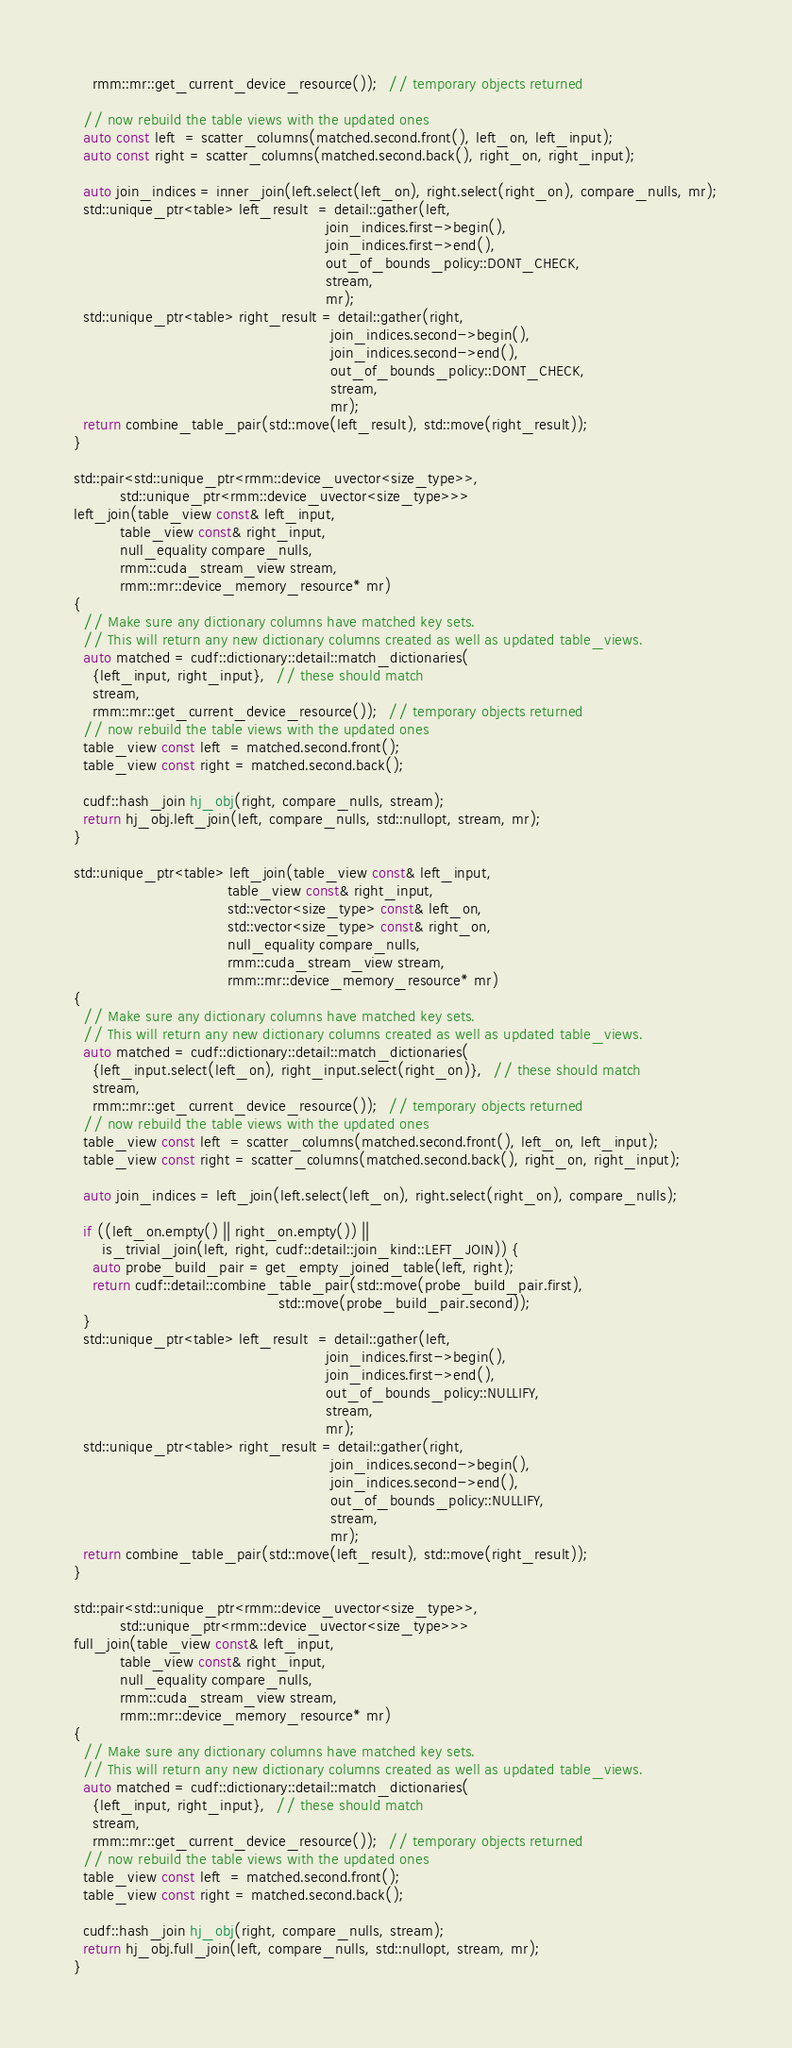Convert code to text. <code><loc_0><loc_0><loc_500><loc_500><_Cuda_>    rmm::mr::get_current_device_resource());  // temporary objects returned

  // now rebuild the table views with the updated ones
  auto const left  = scatter_columns(matched.second.front(), left_on, left_input);
  auto const right = scatter_columns(matched.second.back(), right_on, right_input);

  auto join_indices = inner_join(left.select(left_on), right.select(right_on), compare_nulls, mr);
  std::unique_ptr<table> left_result  = detail::gather(left,
                                                      join_indices.first->begin(),
                                                      join_indices.first->end(),
                                                      out_of_bounds_policy::DONT_CHECK,
                                                      stream,
                                                      mr);
  std::unique_ptr<table> right_result = detail::gather(right,
                                                       join_indices.second->begin(),
                                                       join_indices.second->end(),
                                                       out_of_bounds_policy::DONT_CHECK,
                                                       stream,
                                                       mr);
  return combine_table_pair(std::move(left_result), std::move(right_result));
}

std::pair<std::unique_ptr<rmm::device_uvector<size_type>>,
          std::unique_ptr<rmm::device_uvector<size_type>>>
left_join(table_view const& left_input,
          table_view const& right_input,
          null_equality compare_nulls,
          rmm::cuda_stream_view stream,
          rmm::mr::device_memory_resource* mr)
{
  // Make sure any dictionary columns have matched key sets.
  // This will return any new dictionary columns created as well as updated table_views.
  auto matched = cudf::dictionary::detail::match_dictionaries(
    {left_input, right_input},  // these should match
    stream,
    rmm::mr::get_current_device_resource());  // temporary objects returned
  // now rebuild the table views with the updated ones
  table_view const left  = matched.second.front();
  table_view const right = matched.second.back();

  cudf::hash_join hj_obj(right, compare_nulls, stream);
  return hj_obj.left_join(left, compare_nulls, std::nullopt, stream, mr);
}

std::unique_ptr<table> left_join(table_view const& left_input,
                                 table_view const& right_input,
                                 std::vector<size_type> const& left_on,
                                 std::vector<size_type> const& right_on,
                                 null_equality compare_nulls,
                                 rmm::cuda_stream_view stream,
                                 rmm::mr::device_memory_resource* mr)
{
  // Make sure any dictionary columns have matched key sets.
  // This will return any new dictionary columns created as well as updated table_views.
  auto matched = cudf::dictionary::detail::match_dictionaries(
    {left_input.select(left_on), right_input.select(right_on)},  // these should match
    stream,
    rmm::mr::get_current_device_resource());  // temporary objects returned
  // now rebuild the table views with the updated ones
  table_view const left  = scatter_columns(matched.second.front(), left_on, left_input);
  table_view const right = scatter_columns(matched.second.back(), right_on, right_input);

  auto join_indices = left_join(left.select(left_on), right.select(right_on), compare_nulls);

  if ((left_on.empty() || right_on.empty()) ||
      is_trivial_join(left, right, cudf::detail::join_kind::LEFT_JOIN)) {
    auto probe_build_pair = get_empty_joined_table(left, right);
    return cudf::detail::combine_table_pair(std::move(probe_build_pair.first),
                                            std::move(probe_build_pair.second));
  }
  std::unique_ptr<table> left_result  = detail::gather(left,
                                                      join_indices.first->begin(),
                                                      join_indices.first->end(),
                                                      out_of_bounds_policy::NULLIFY,
                                                      stream,
                                                      mr);
  std::unique_ptr<table> right_result = detail::gather(right,
                                                       join_indices.second->begin(),
                                                       join_indices.second->end(),
                                                       out_of_bounds_policy::NULLIFY,
                                                       stream,
                                                       mr);
  return combine_table_pair(std::move(left_result), std::move(right_result));
}

std::pair<std::unique_ptr<rmm::device_uvector<size_type>>,
          std::unique_ptr<rmm::device_uvector<size_type>>>
full_join(table_view const& left_input,
          table_view const& right_input,
          null_equality compare_nulls,
          rmm::cuda_stream_view stream,
          rmm::mr::device_memory_resource* mr)
{
  // Make sure any dictionary columns have matched key sets.
  // This will return any new dictionary columns created as well as updated table_views.
  auto matched = cudf::dictionary::detail::match_dictionaries(
    {left_input, right_input},  // these should match
    stream,
    rmm::mr::get_current_device_resource());  // temporary objects returned
  // now rebuild the table views with the updated ones
  table_view const left  = matched.second.front();
  table_view const right = matched.second.back();

  cudf::hash_join hj_obj(right, compare_nulls, stream);
  return hj_obj.full_join(left, compare_nulls, std::nullopt, stream, mr);
}
</code> 